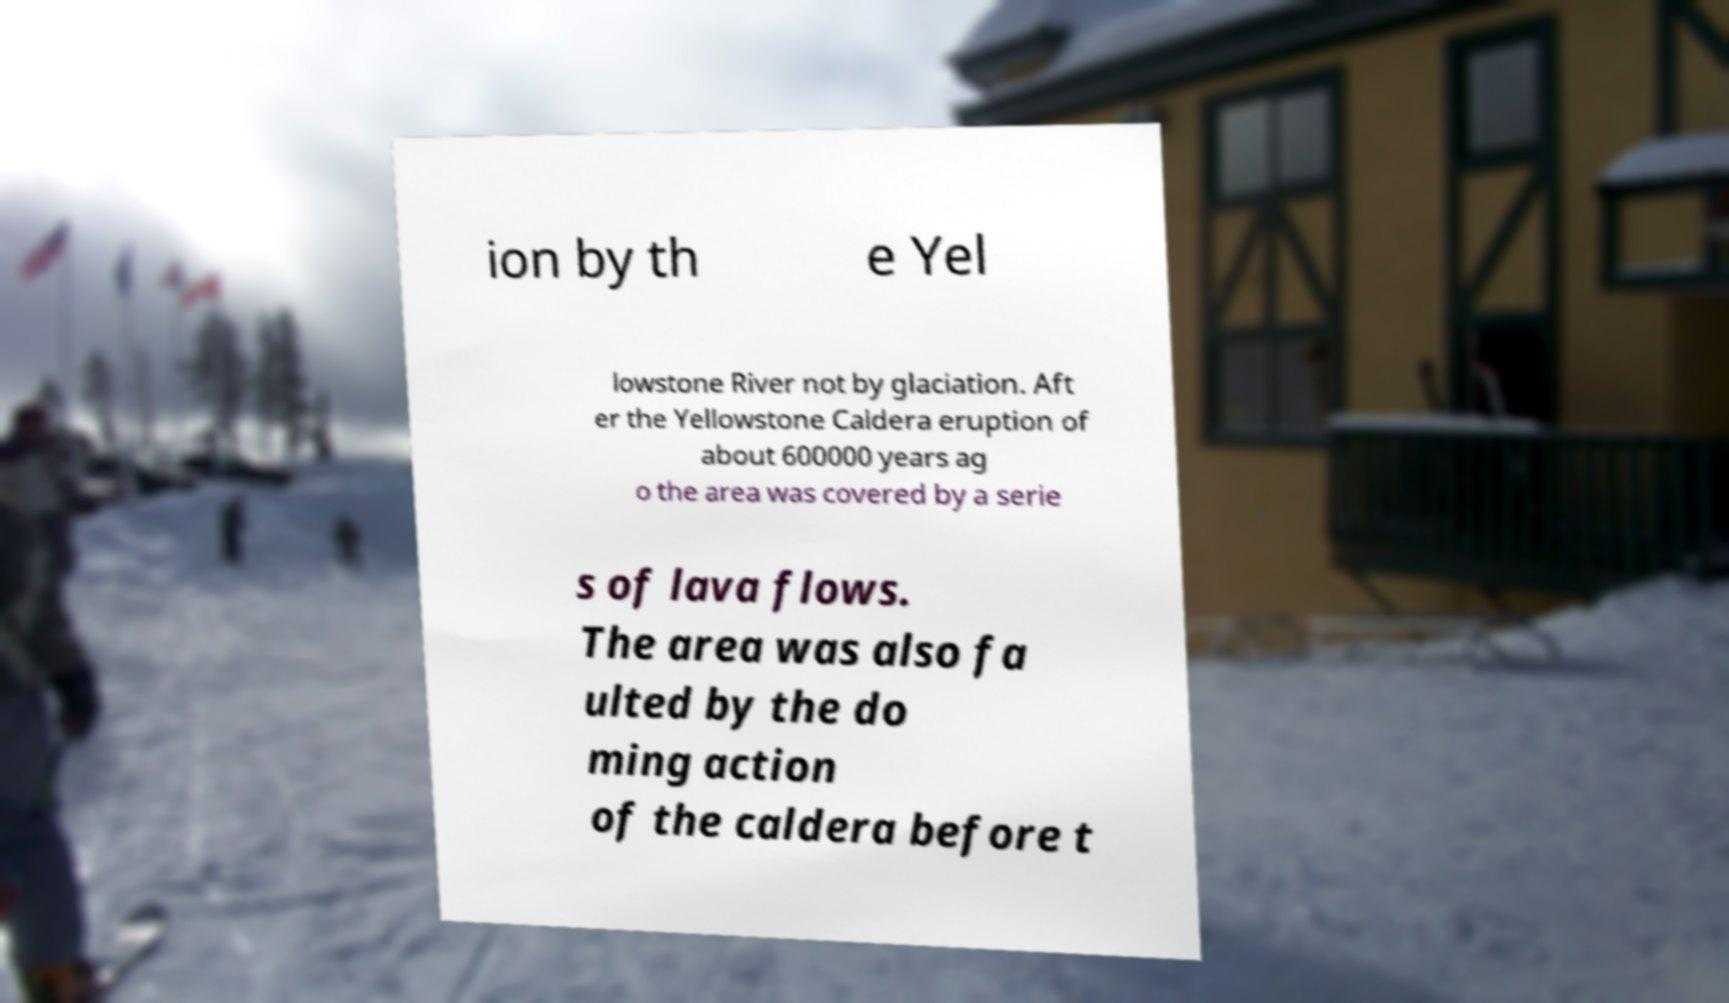There's text embedded in this image that I need extracted. Can you transcribe it verbatim? ion by th e Yel lowstone River not by glaciation. Aft er the Yellowstone Caldera eruption of about 600000 years ag o the area was covered by a serie s of lava flows. The area was also fa ulted by the do ming action of the caldera before t 